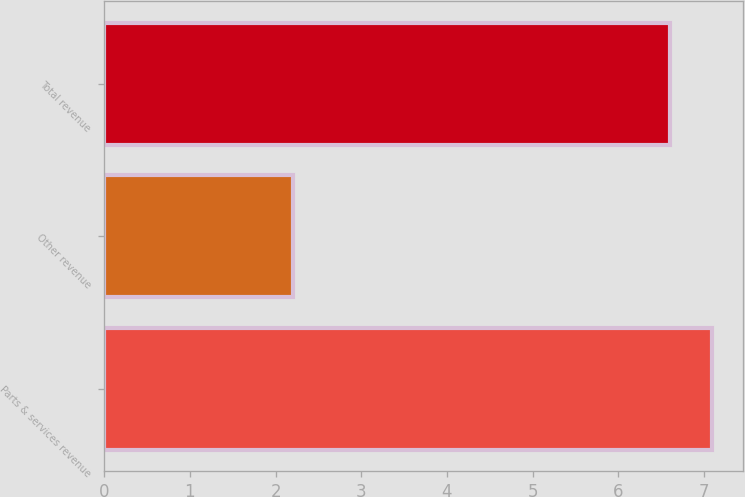Convert chart to OTSL. <chart><loc_0><loc_0><loc_500><loc_500><bar_chart><fcel>Parts & services revenue<fcel>Other revenue<fcel>Total revenue<nl><fcel>7.1<fcel>2.2<fcel>6.6<nl></chart> 